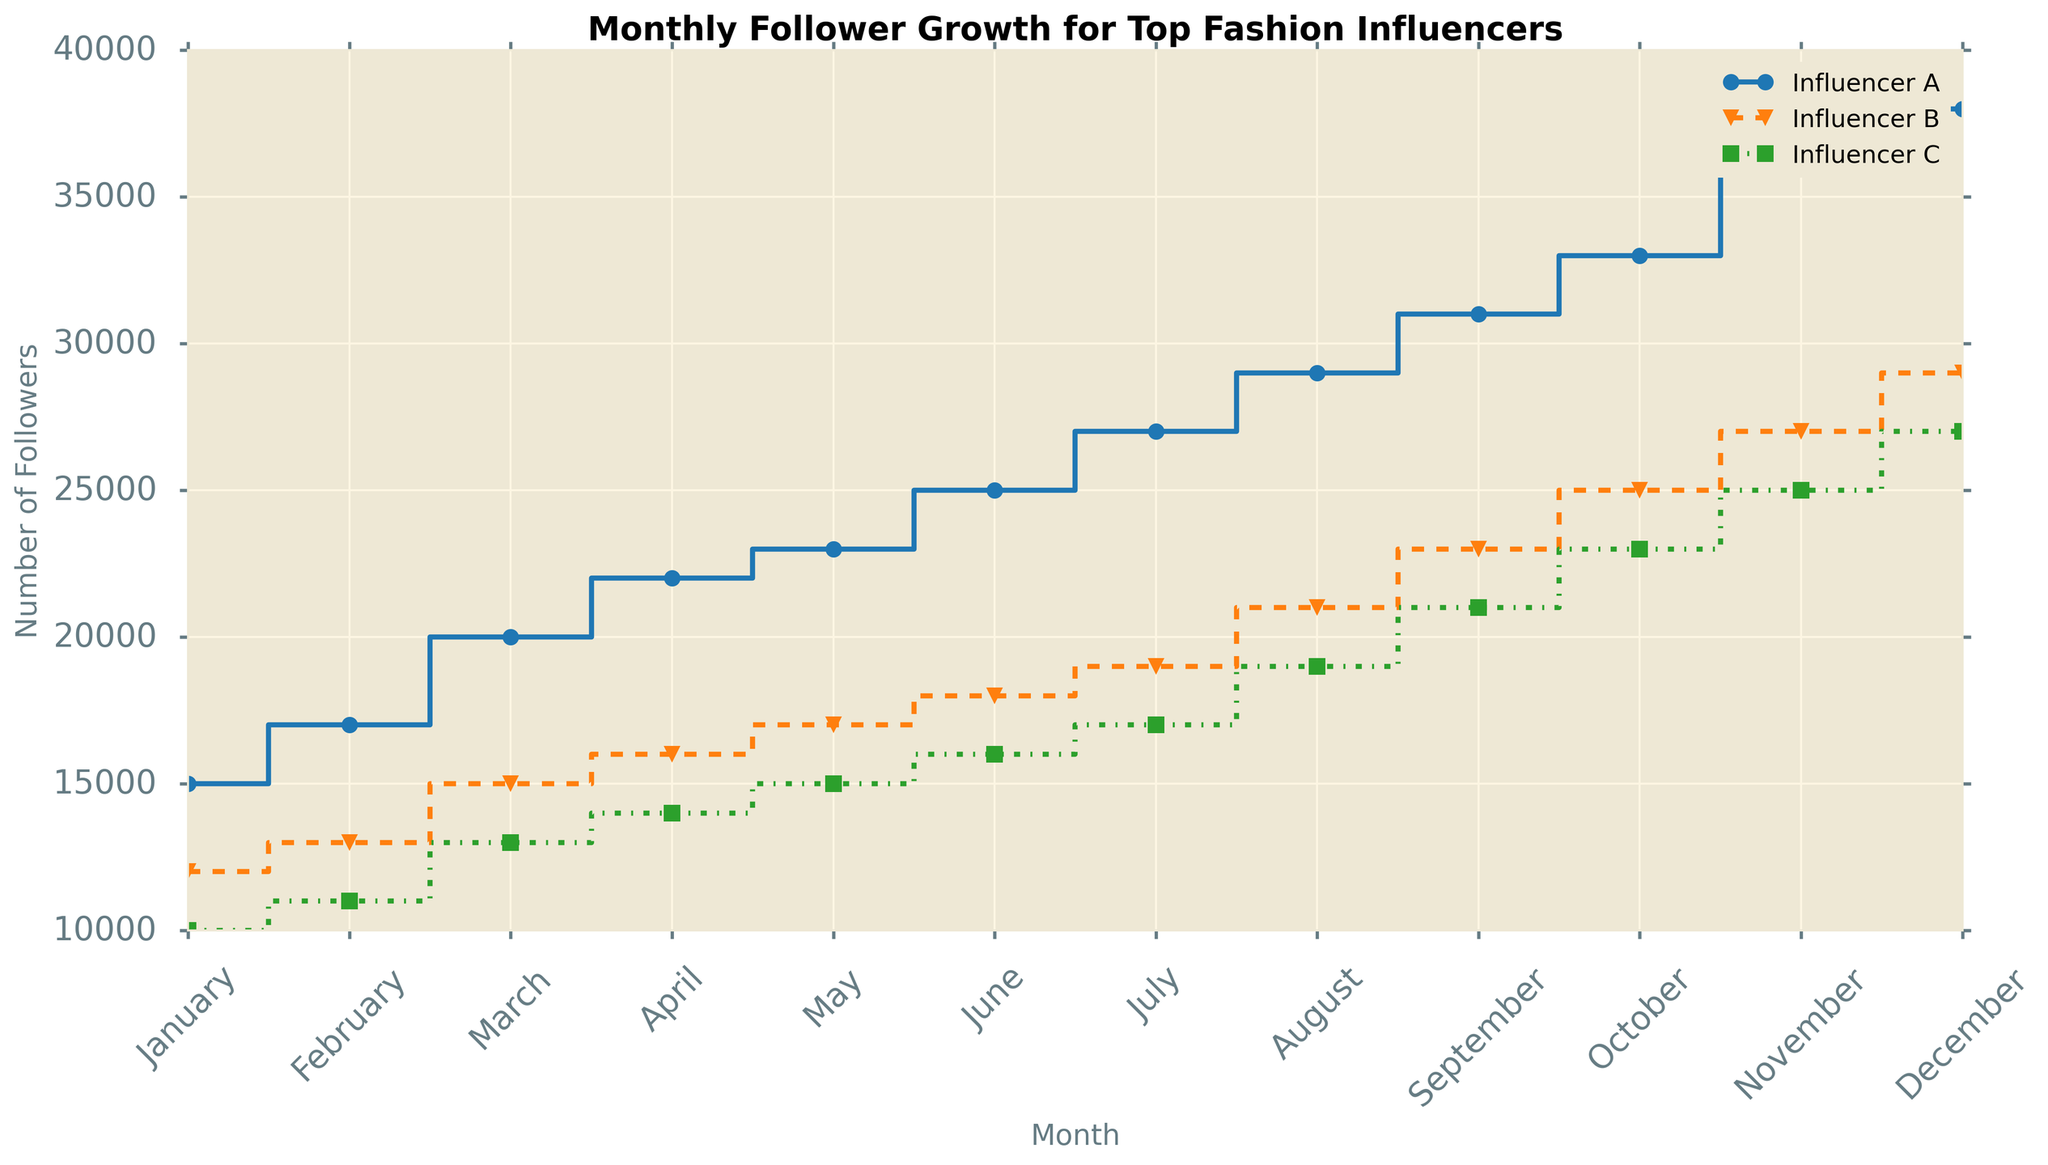How many more followers did Influencer A gain from January to December compared to Influencer C? Influencer A gained 23,000 followers (38,000 - 15,000) from January to December, while Influencer C gained 17,000 followers (27,000 - 10,000). The difference is 23,000 - 17,000.
Answer: 6,000 Which month saw the largest increase in followers for Influencer B? Comparing month-over-month growth for Influencer B: (Feb-Jan) 1,000, (Mar-Feb) 2,000, (Apr-Mar) 1,000, (May-Apr) 1,000, (Jun-May) 1,000, (Jul-Jun) 1,000, (Aug-Jul) 2,000, (Sep-Aug) 2,000, (Oct-Sep) 2,000, (Nov-Oct) 2,000, (Dec-Nov) 2,000.
Answer: March Between Influencer B and Influencer C, which influencer had more consistent follower growth throughout the year? Influencer B had variable increases ranging from 1,000 to 2,000, while Influencer C had consistent increases of around 1,000 to 2,000 each month.
Answer: Influencer C What's the difference in the number of followers between Influencer A and Influencer B in August? In August, Influencer A had 29,000 followers and Influencer B had 21,000 followers. The difference is 29,000 - 21,000.
Answer: 8,000 What is the average monthly growth rate for Influencer C? Gain from January to December for Influencer C is 27,000 - 10,000 = 17,000 over 12 months. The average monthly growth rate is 17,000 / 12.
Answer: 1,417 If Influencer A continues to grow at the same rate, how many followers will they have next June? Influencer A's monthly growth from January to December is (38,000 - 15,000) / 12 = 1,917. By next June (6 months ahead), they would have 38,000 + (1,917 * 6).
Answer: 49,502 Which influencer had the highest number of followers in October? By visual inspection, Influencer A's line is the highest in October with 33,000 followers.
Answer: Influencer A How many total followers did all three influencers have by the end of the year (December)? Adding the followers for December: 38,000 (A) + 29,000 (B) + 27,000 (C).
Answer: 94,000 Did Influencer B ever surpass Influencer A in follower count at any point in the year? By visual inspection, Influencer B's line is always lower than Influencer A's line throughout the year.
Answer: No What is the difference in the total annual growth of followers between Influencer A and Influencer B? Influencer A's total growth: 38,000 - 15,000 = 23,000. Influencer B's total growth: 29,000 - 12,000 = 17,000. The difference is 23,000 - 17,000.
Answer: 6,000 